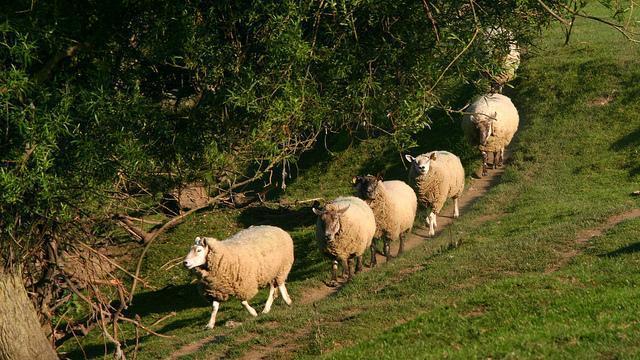How many sheep are walking through the grass?
Give a very brief answer. 6. How many dogs are there?
Give a very brief answer. 0. How many animals are there?
Give a very brief answer. 6. How many different species of animals can be seen in this picture?
Give a very brief answer. 1. How many animals are in the field?
Give a very brief answer. 6. How many sheep are in the photo?
Give a very brief answer. 5. How many giraffes are not drinking?
Give a very brief answer. 0. 